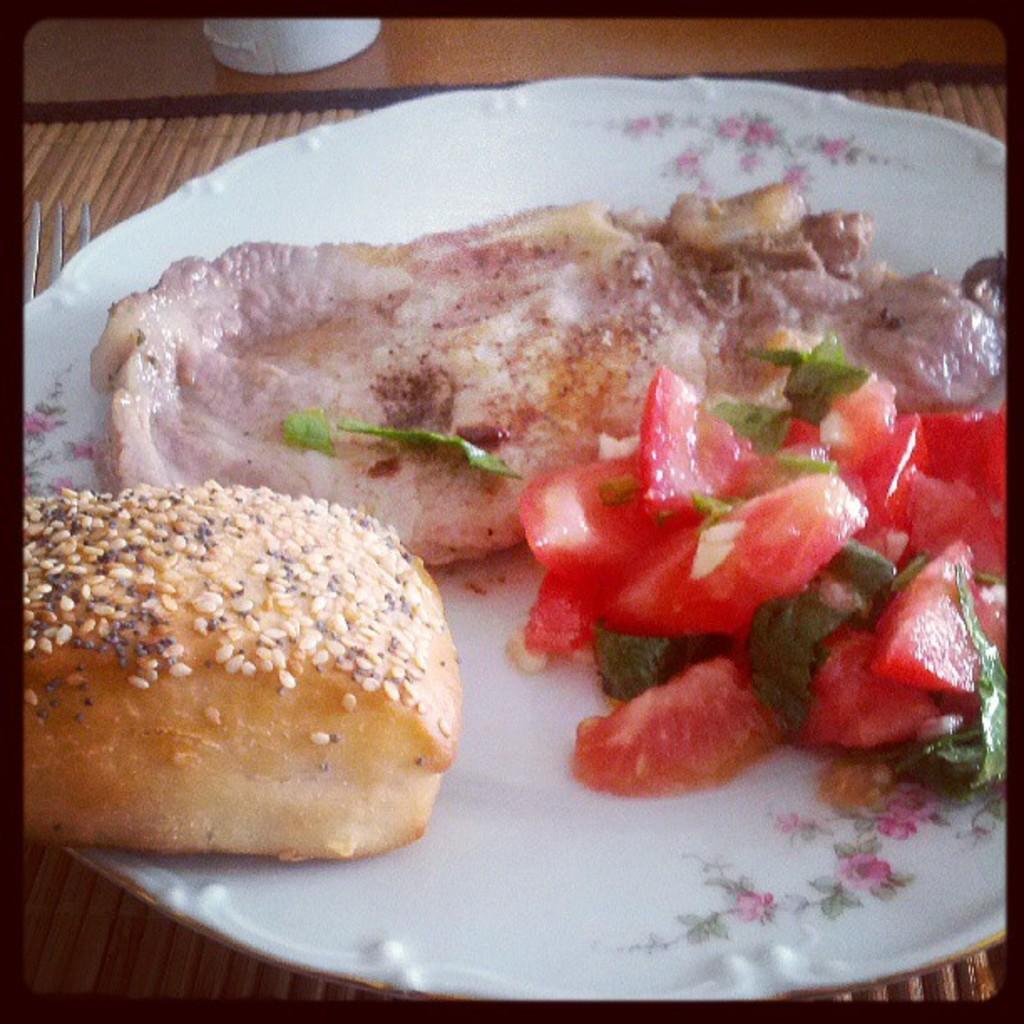Describe this image in one or two sentences. In the picture we can see some food item which is in white color plate. 